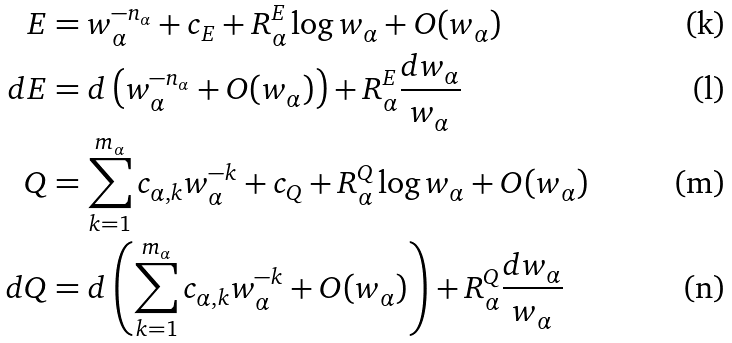<formula> <loc_0><loc_0><loc_500><loc_500>E & = w _ { \alpha } ^ { - n _ { \alpha } } + c _ { E } + R ^ { E } _ { \alpha } \log w _ { \alpha } + O ( w _ { \alpha } ) \\ d E & = d \left ( w _ { \alpha } ^ { - n _ { \alpha } } + O ( w _ { \alpha } ) \right ) + R ^ { E } _ { \alpha } \frac { d w _ { \alpha } } { w _ { \alpha } } \\ Q & = \sum _ { k = 1 } ^ { m _ { \alpha } } c _ { \alpha , k } w _ { \alpha } ^ { - k } + c _ { Q } + R _ { \alpha } ^ { Q } \log w _ { \alpha } + O ( w _ { \alpha } ) \\ d Q & = d \left ( \sum _ { k = 1 } ^ { m _ { \alpha } } c _ { \alpha , k } w _ { \alpha } ^ { - k } + O ( w _ { \alpha } ) \right ) + R ^ { Q } _ { \alpha } \frac { d w _ { \alpha } } { w _ { \alpha } }</formula> 